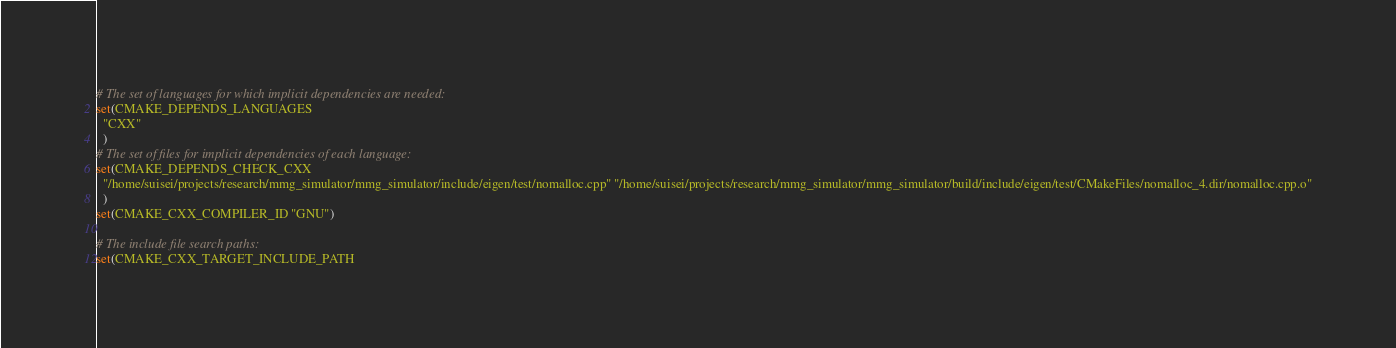<code> <loc_0><loc_0><loc_500><loc_500><_CMake_># The set of languages for which implicit dependencies are needed:
set(CMAKE_DEPENDS_LANGUAGES
  "CXX"
  )
# The set of files for implicit dependencies of each language:
set(CMAKE_DEPENDS_CHECK_CXX
  "/home/suisei/projects/research/mmg_simulator/mmg_simulator/include/eigen/test/nomalloc.cpp" "/home/suisei/projects/research/mmg_simulator/mmg_simulator/build/include/eigen/test/CMakeFiles/nomalloc_4.dir/nomalloc.cpp.o"
  )
set(CMAKE_CXX_COMPILER_ID "GNU")

# The include file search paths:
set(CMAKE_CXX_TARGET_INCLUDE_PATH</code> 